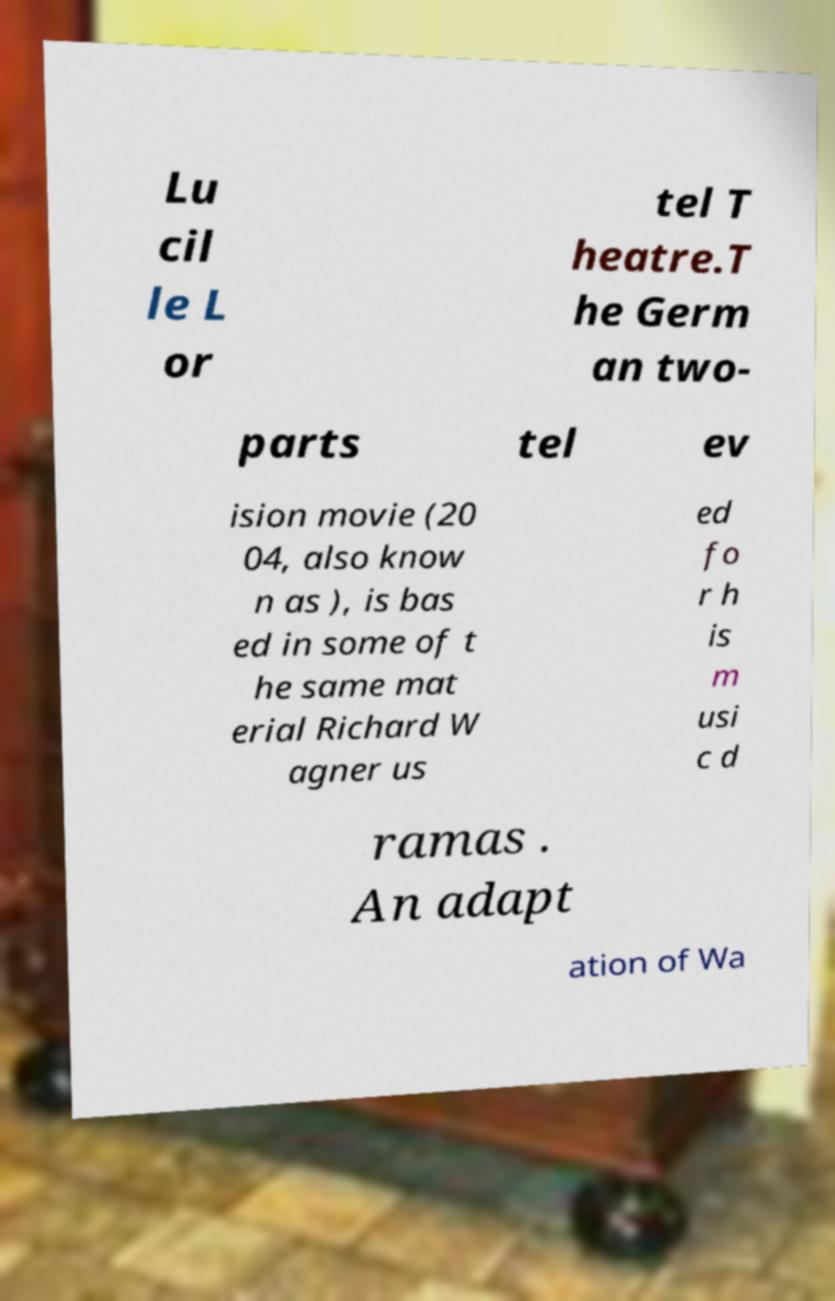There's text embedded in this image that I need extracted. Can you transcribe it verbatim? Lu cil le L or tel T heatre.T he Germ an two- parts tel ev ision movie (20 04, also know n as ), is bas ed in some of t he same mat erial Richard W agner us ed fo r h is m usi c d ramas . An adapt ation of Wa 